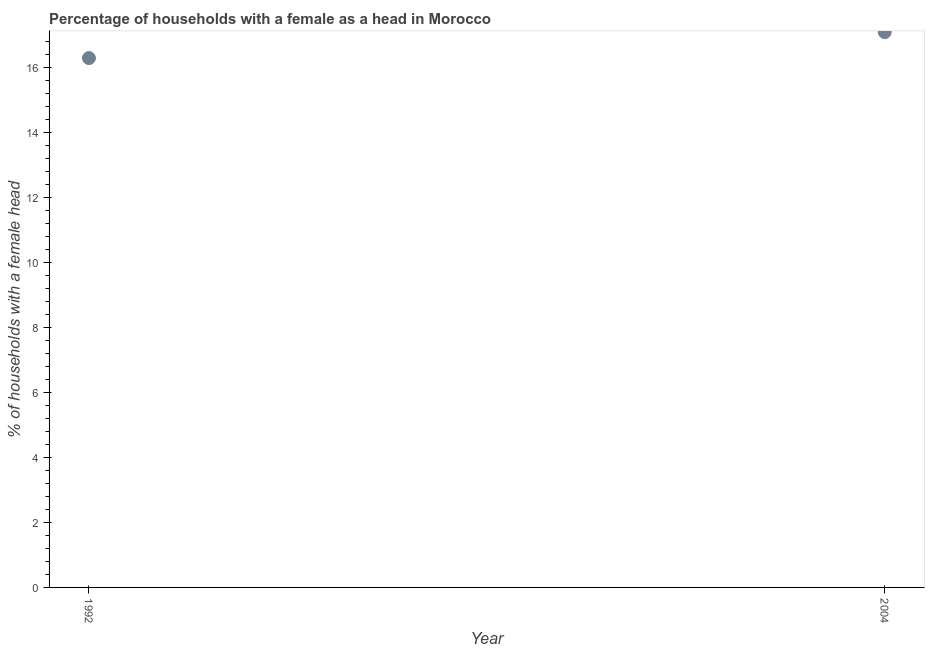What is the number of female supervised households in 2004?
Your response must be concise. 17.1. Across all years, what is the maximum number of female supervised households?
Your response must be concise. 17.1. Across all years, what is the minimum number of female supervised households?
Give a very brief answer. 16.3. In which year was the number of female supervised households maximum?
Provide a succinct answer. 2004. In which year was the number of female supervised households minimum?
Provide a short and direct response. 1992. What is the sum of the number of female supervised households?
Provide a succinct answer. 33.4. What is the difference between the number of female supervised households in 1992 and 2004?
Your answer should be compact. -0.8. What is the average number of female supervised households per year?
Offer a very short reply. 16.7. What is the median number of female supervised households?
Offer a terse response. 16.7. In how many years, is the number of female supervised households greater than 10.8 %?
Offer a very short reply. 2. What is the ratio of the number of female supervised households in 1992 to that in 2004?
Offer a very short reply. 0.95. Is the number of female supervised households in 1992 less than that in 2004?
Provide a succinct answer. Yes. In how many years, is the number of female supervised households greater than the average number of female supervised households taken over all years?
Offer a very short reply. 1. Does the number of female supervised households monotonically increase over the years?
Provide a succinct answer. Yes. What is the difference between two consecutive major ticks on the Y-axis?
Your answer should be compact. 2. What is the title of the graph?
Offer a terse response. Percentage of households with a female as a head in Morocco. What is the label or title of the X-axis?
Keep it short and to the point. Year. What is the label or title of the Y-axis?
Offer a terse response. % of households with a female head. What is the difference between the % of households with a female head in 1992 and 2004?
Your response must be concise. -0.8. What is the ratio of the % of households with a female head in 1992 to that in 2004?
Give a very brief answer. 0.95. 